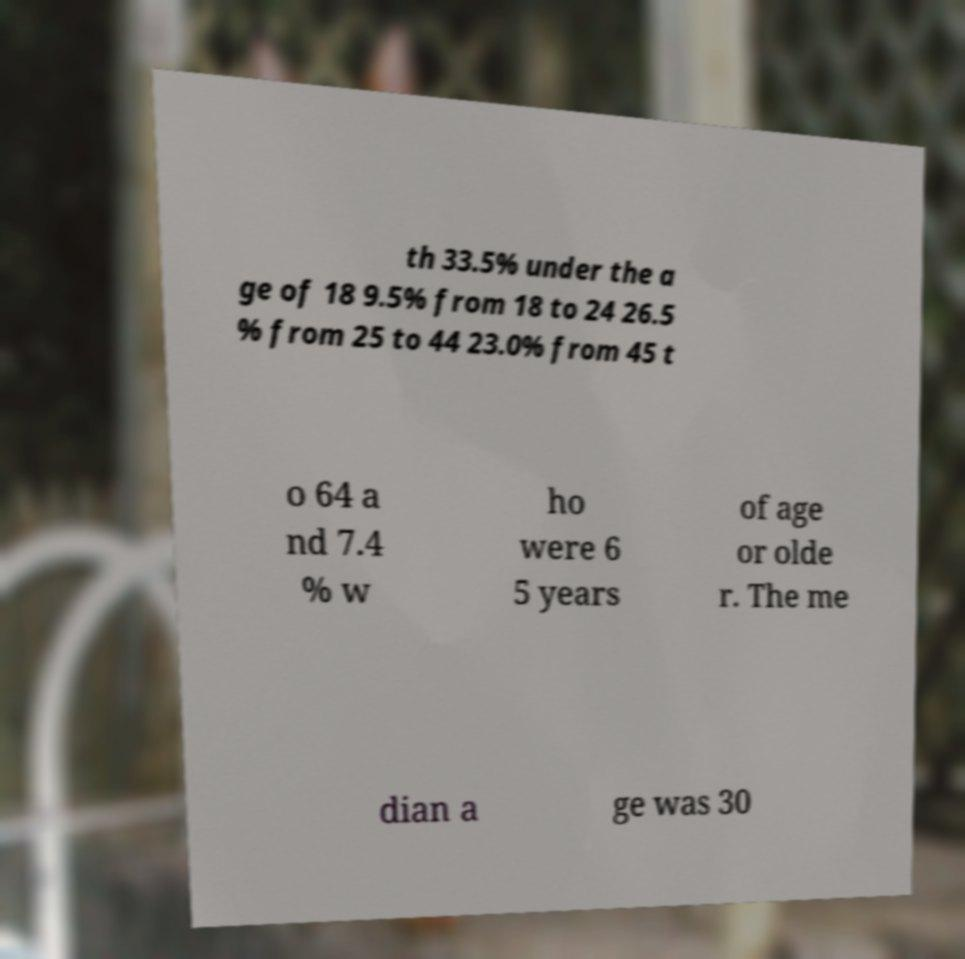Could you extract and type out the text from this image? th 33.5% under the a ge of 18 9.5% from 18 to 24 26.5 % from 25 to 44 23.0% from 45 t o 64 a nd 7.4 % w ho were 6 5 years of age or olde r. The me dian a ge was 30 